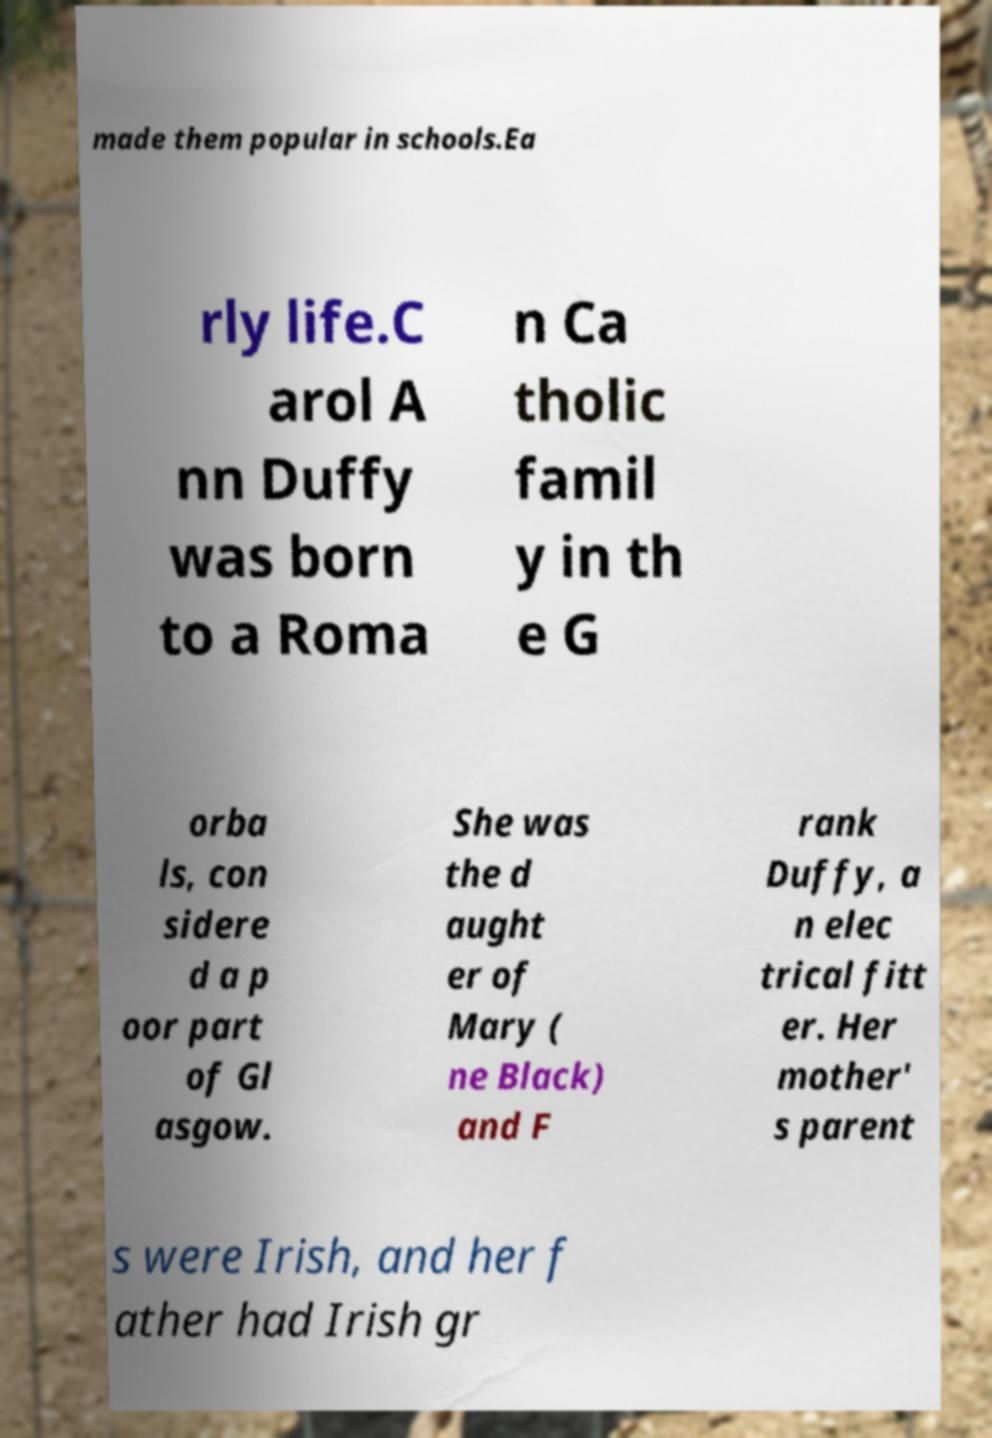Could you extract and type out the text from this image? made them popular in schools.Ea rly life.C arol A nn Duffy was born to a Roma n Ca tholic famil y in th e G orba ls, con sidere d a p oor part of Gl asgow. She was the d aught er of Mary ( ne Black) and F rank Duffy, a n elec trical fitt er. Her mother' s parent s were Irish, and her f ather had Irish gr 